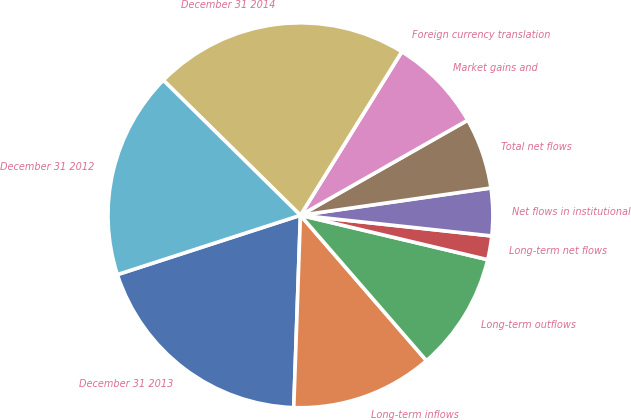Convert chart. <chart><loc_0><loc_0><loc_500><loc_500><pie_chart><fcel>December 31 2013<fcel>Long-term inflows<fcel>Long-term outflows<fcel>Long-term net flows<fcel>Net flows in institutional<fcel>Total net flows<fcel>Market gains and<fcel>Foreign currency translation<fcel>December 31 2014<fcel>December 31 2012<nl><fcel>19.46%<fcel>11.92%<fcel>9.93%<fcel>1.99%<fcel>3.98%<fcel>5.96%<fcel>7.95%<fcel>0.0%<fcel>21.45%<fcel>17.37%<nl></chart> 